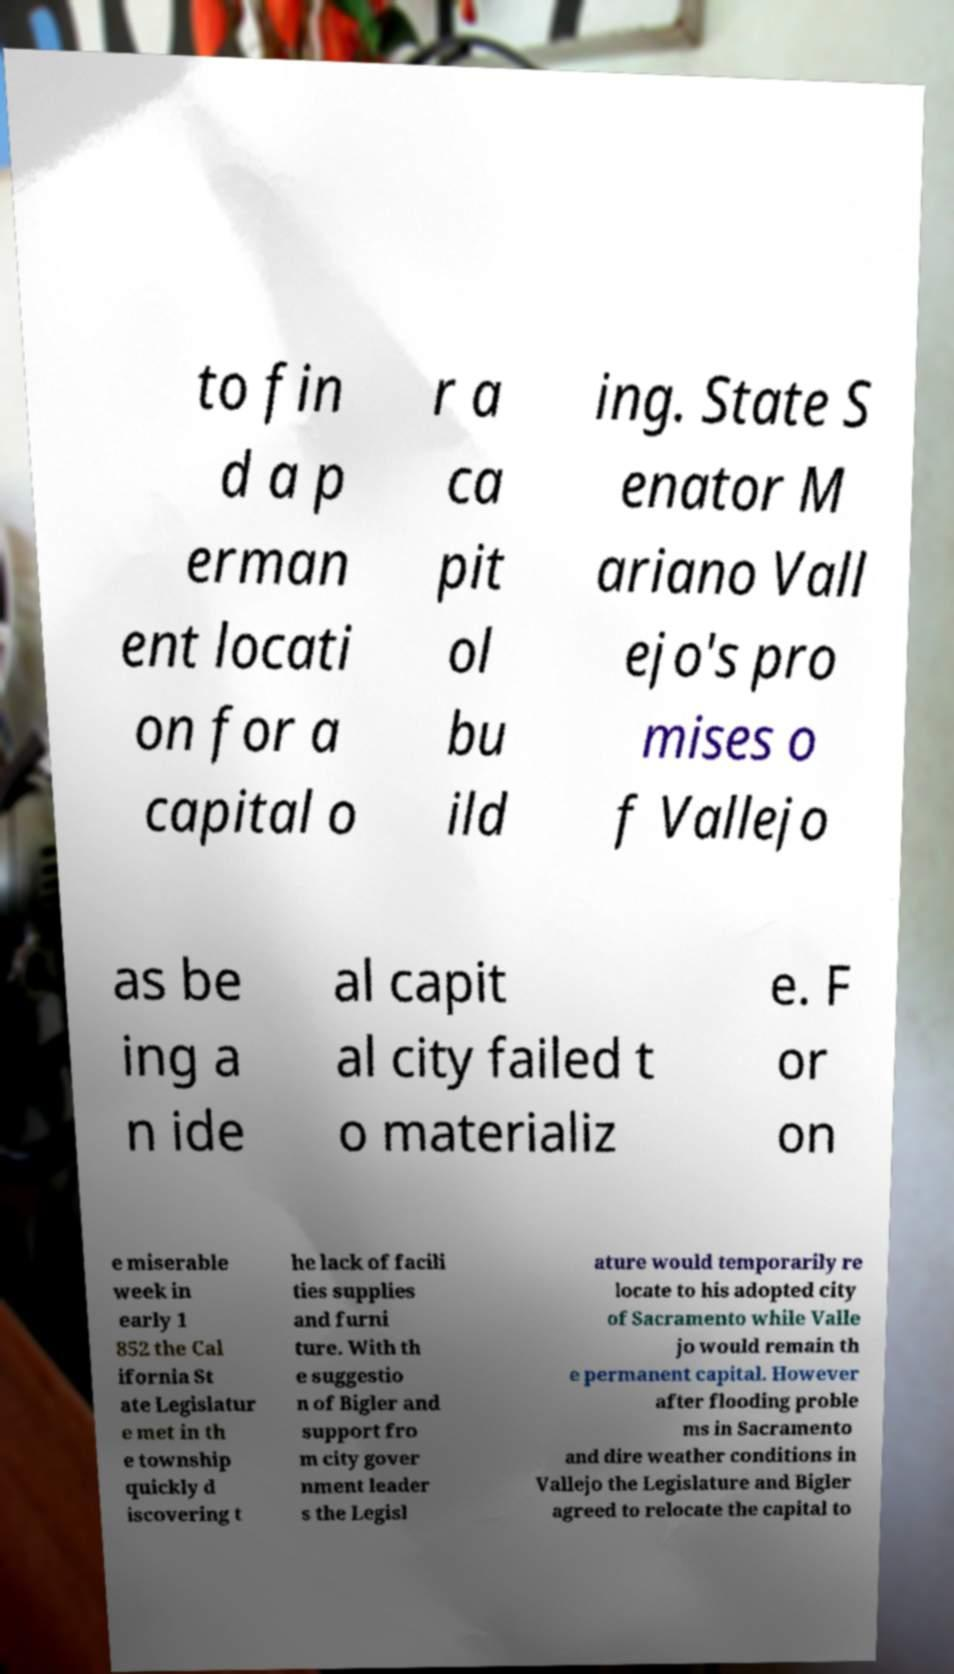Could you assist in decoding the text presented in this image and type it out clearly? to fin d a p erman ent locati on for a capital o r a ca pit ol bu ild ing. State S enator M ariano Vall ejo's pro mises o f Vallejo as be ing a n ide al capit al city failed t o materializ e. F or on e miserable week in early 1 852 the Cal ifornia St ate Legislatur e met in th e township quickly d iscovering t he lack of facili ties supplies and furni ture. With th e suggestio n of Bigler and support fro m city gover nment leader s the Legisl ature would temporarily re locate to his adopted city of Sacramento while Valle jo would remain th e permanent capital. However after flooding proble ms in Sacramento and dire weather conditions in Vallejo the Legislature and Bigler agreed to relocate the capital to 